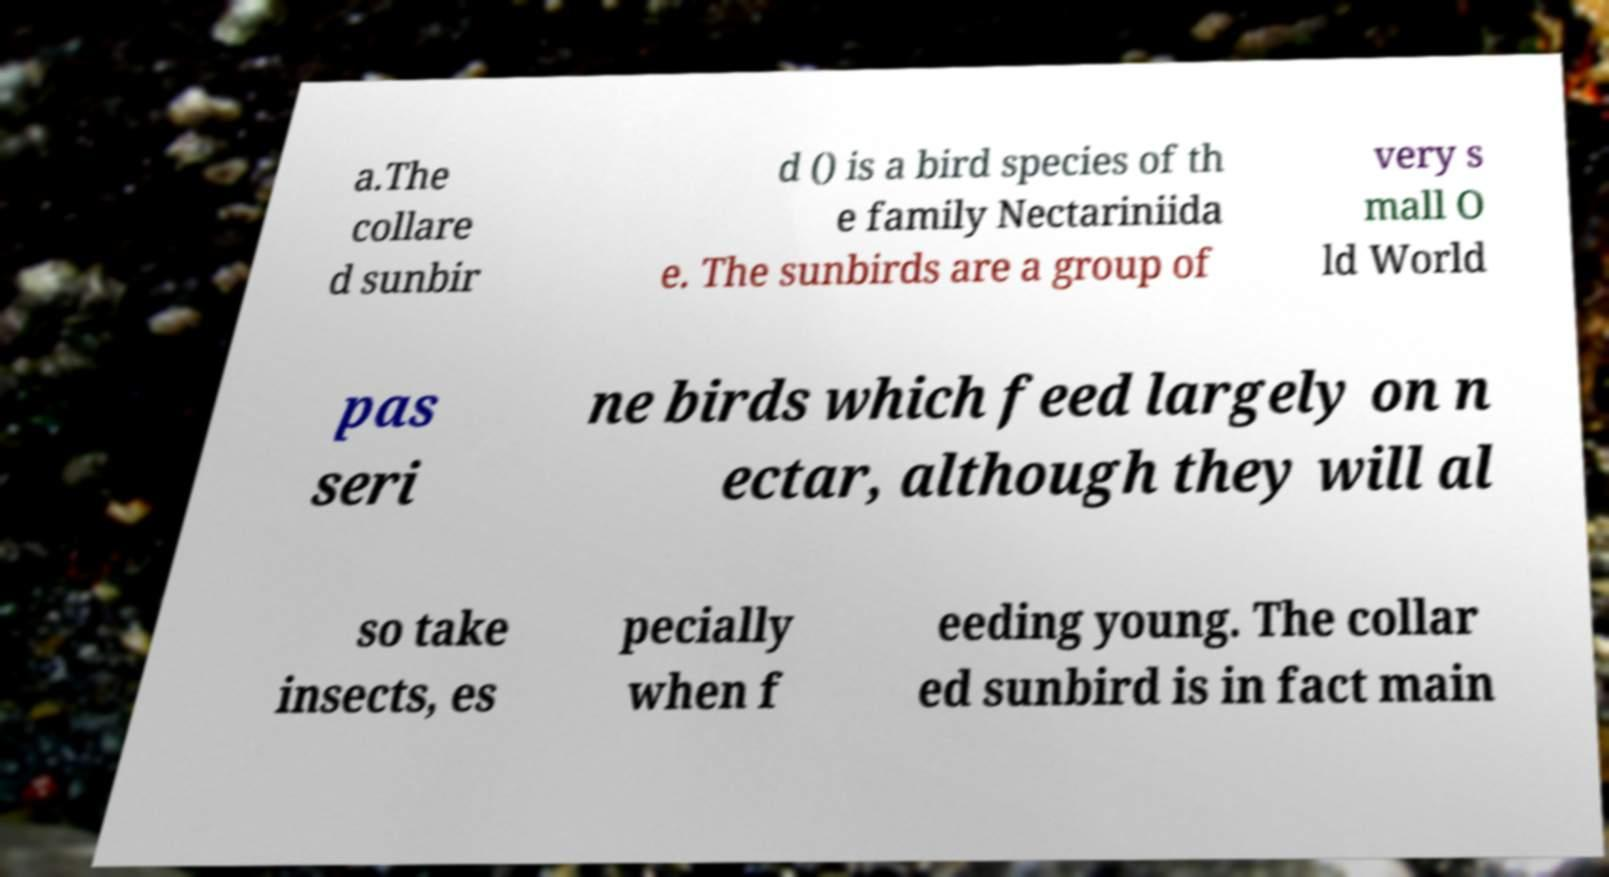Could you assist in decoding the text presented in this image and type it out clearly? a.The collare d sunbir d () is a bird species of th e family Nectariniida e. The sunbirds are a group of very s mall O ld World pas seri ne birds which feed largely on n ectar, although they will al so take insects, es pecially when f eeding young. The collar ed sunbird is in fact main 